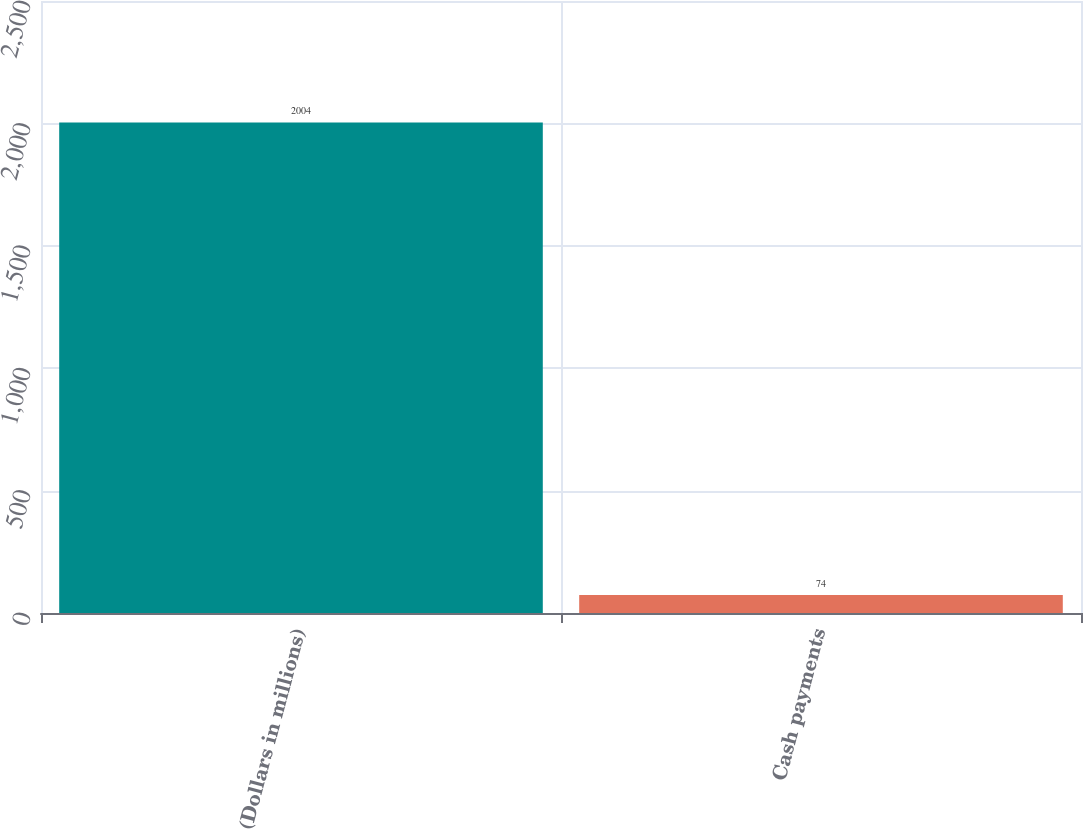Convert chart. <chart><loc_0><loc_0><loc_500><loc_500><bar_chart><fcel>(Dollars in millions)<fcel>Cash payments<nl><fcel>2004<fcel>74<nl></chart> 